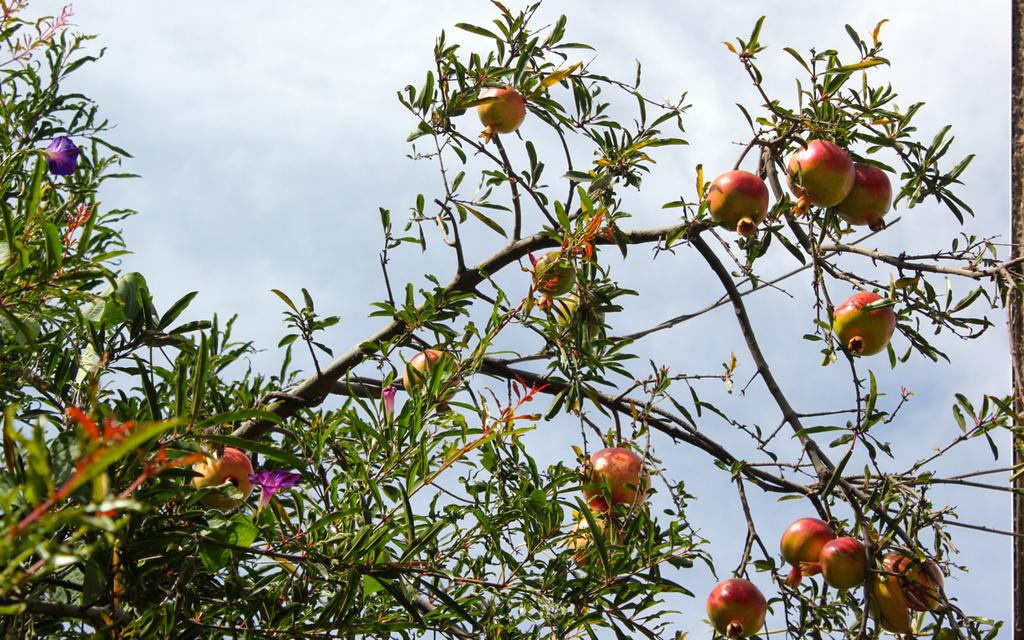What type of vegetation is on the tree in the image? There are fruits and flowers on the tree in the image. What can be seen in the background of the image? The sky is visible in the background of the image. Where is the hose connected to the tree in the image? There is no hose present in the image. What type of bird is sitting on the tree in the image? There are no birds visible in the image. 